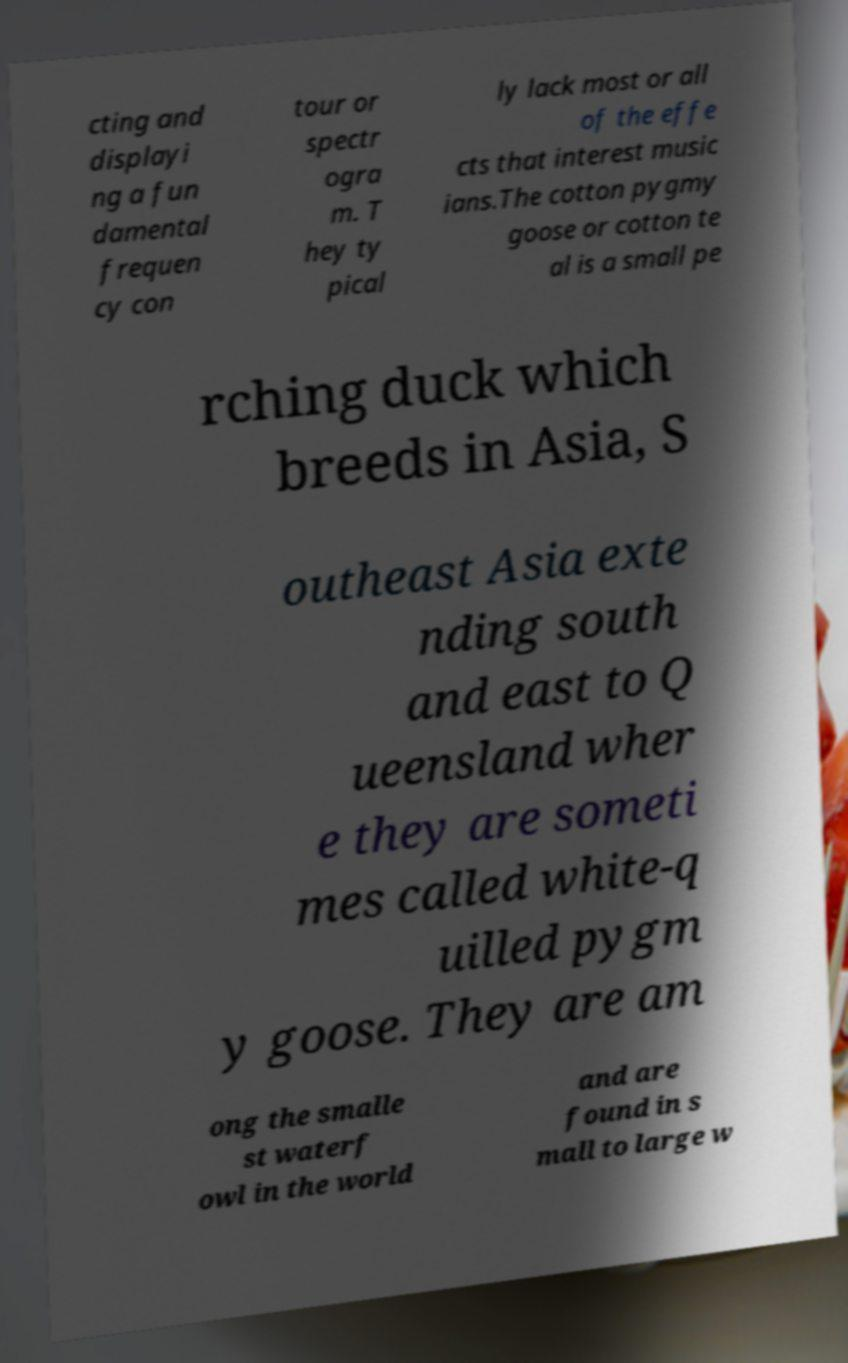Can you accurately transcribe the text from the provided image for me? cting and displayi ng a fun damental frequen cy con tour or spectr ogra m. T hey ty pical ly lack most or all of the effe cts that interest music ians.The cotton pygmy goose or cotton te al is a small pe rching duck which breeds in Asia, S outheast Asia exte nding south and east to Q ueensland wher e they are someti mes called white-q uilled pygm y goose. They are am ong the smalle st waterf owl in the world and are found in s mall to large w 